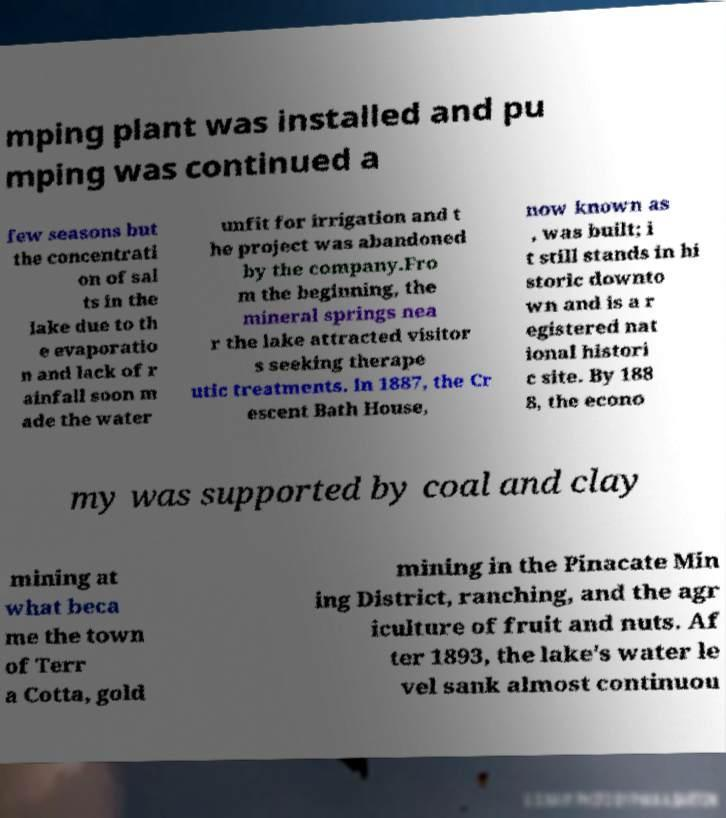I need the written content from this picture converted into text. Can you do that? mping plant was installed and pu mping was continued a few seasons but the concentrati on of sal ts in the lake due to th e evaporatio n and lack of r ainfall soon m ade the water unfit for irrigation and t he project was abandoned by the company.Fro m the beginning, the mineral springs nea r the lake attracted visitor s seeking therape utic treatments. In 1887, the Cr escent Bath House, now known as , was built; i t still stands in hi storic downto wn and is a r egistered nat ional histori c site. By 188 8, the econo my was supported by coal and clay mining at what beca me the town of Terr a Cotta, gold mining in the Pinacate Min ing District, ranching, and the agr iculture of fruit and nuts. Af ter 1893, the lake's water le vel sank almost continuou 